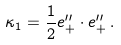Convert formula to latex. <formula><loc_0><loc_0><loc_500><loc_500>\kappa _ { 1 } = \frac { 1 } { 2 } e _ { + } ^ { \prime \prime } \cdot e _ { + } ^ { \prime \prime } \, .</formula> 